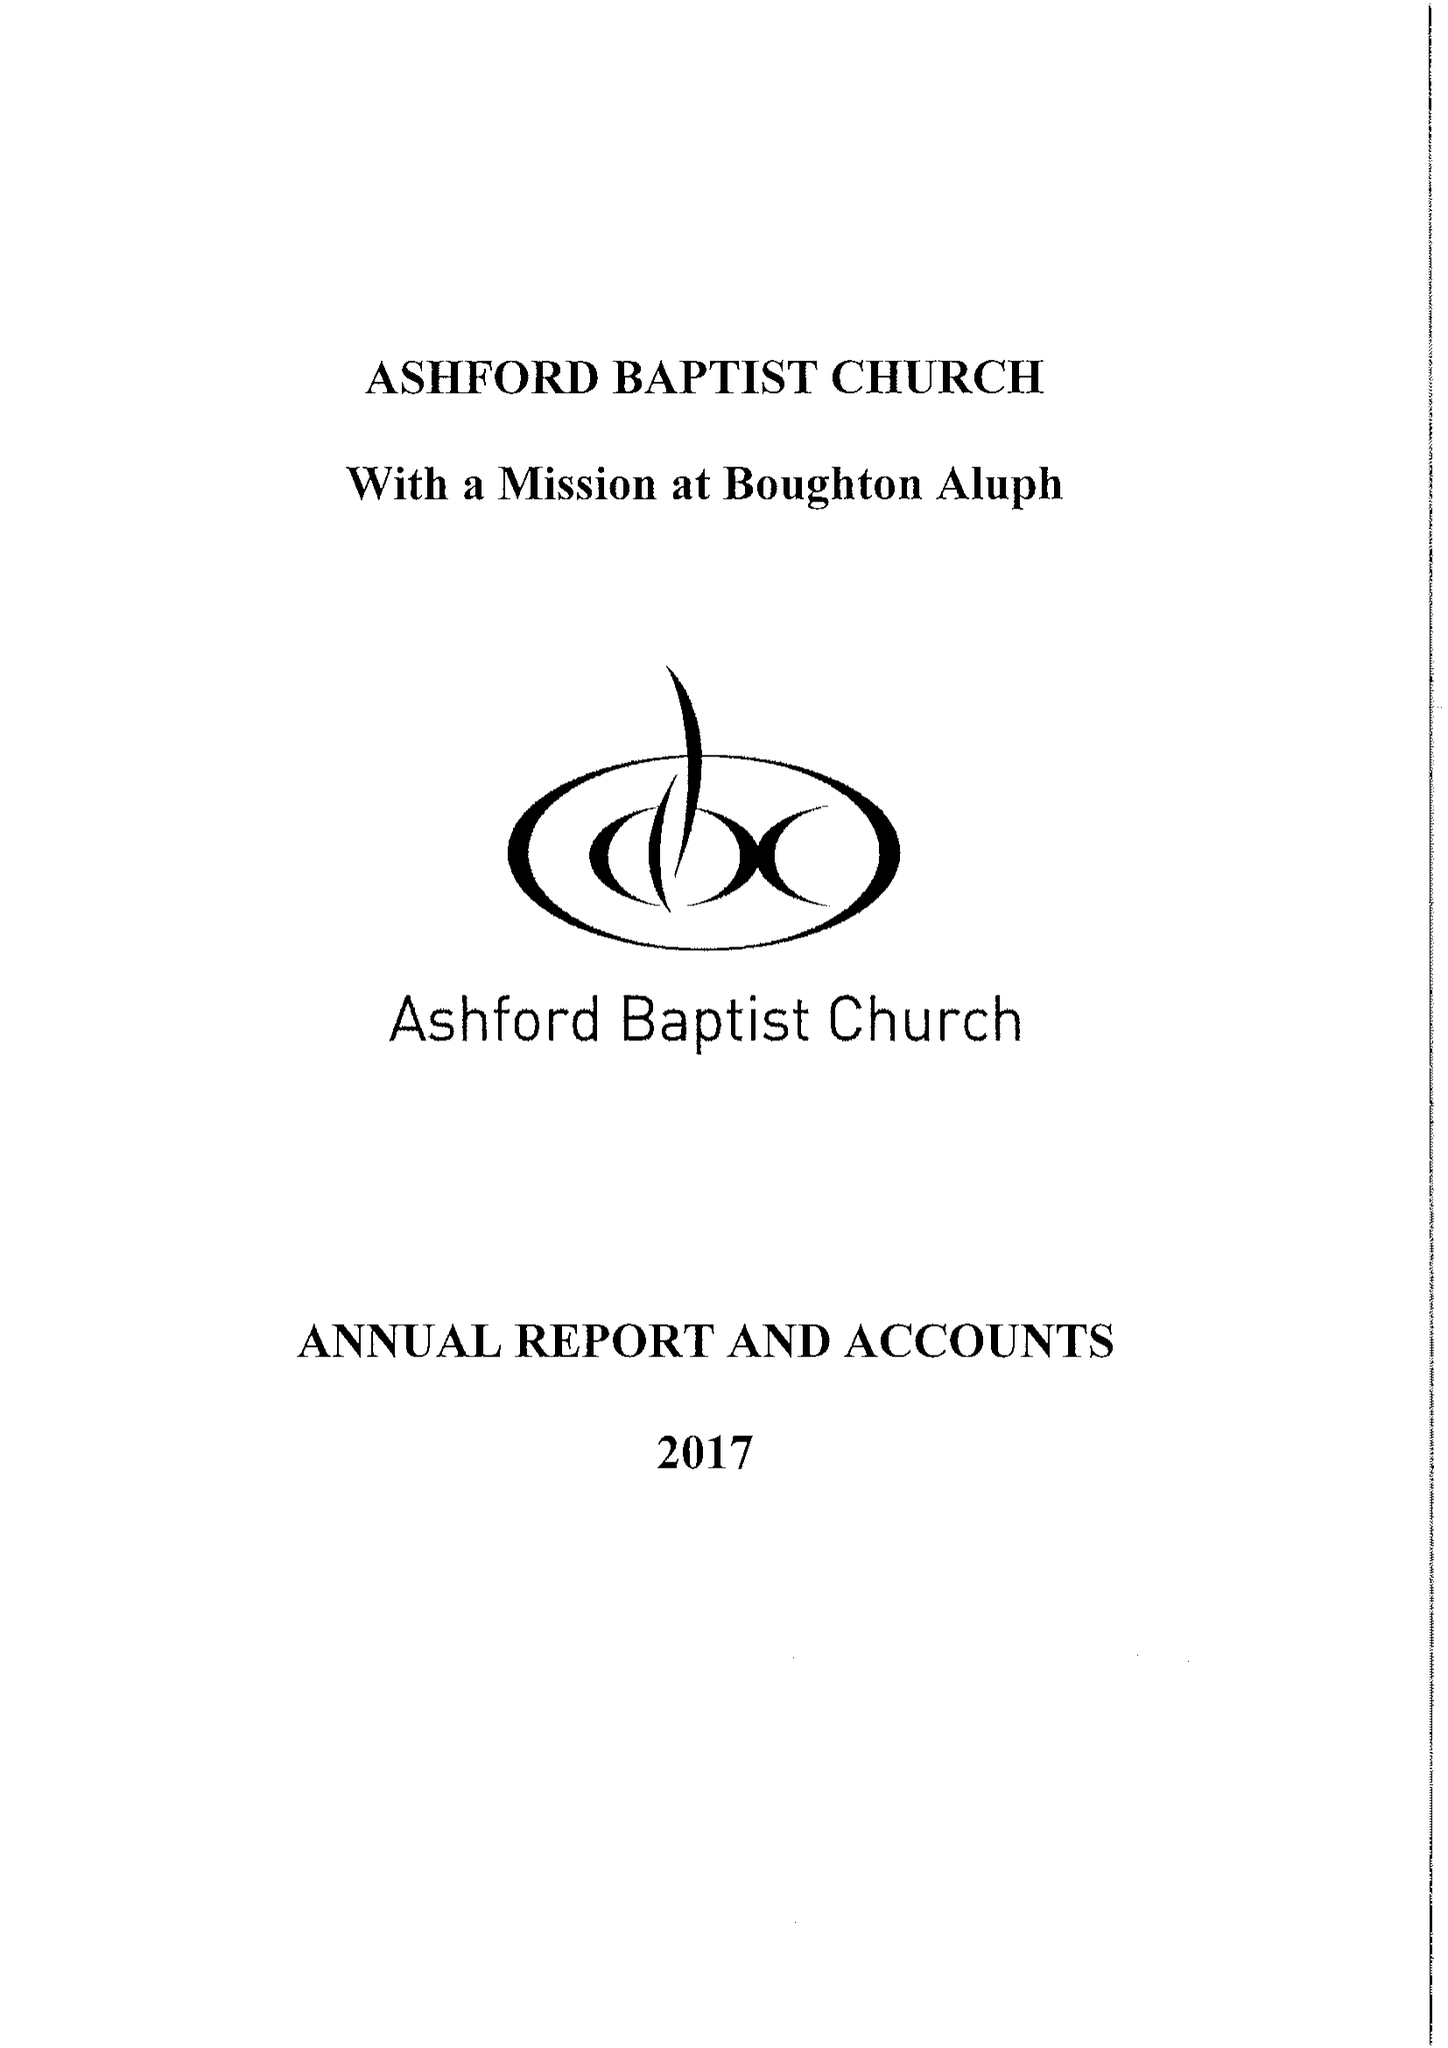What is the value for the charity_name?
Answer the question using a single word or phrase. Ashford Baptist Church 